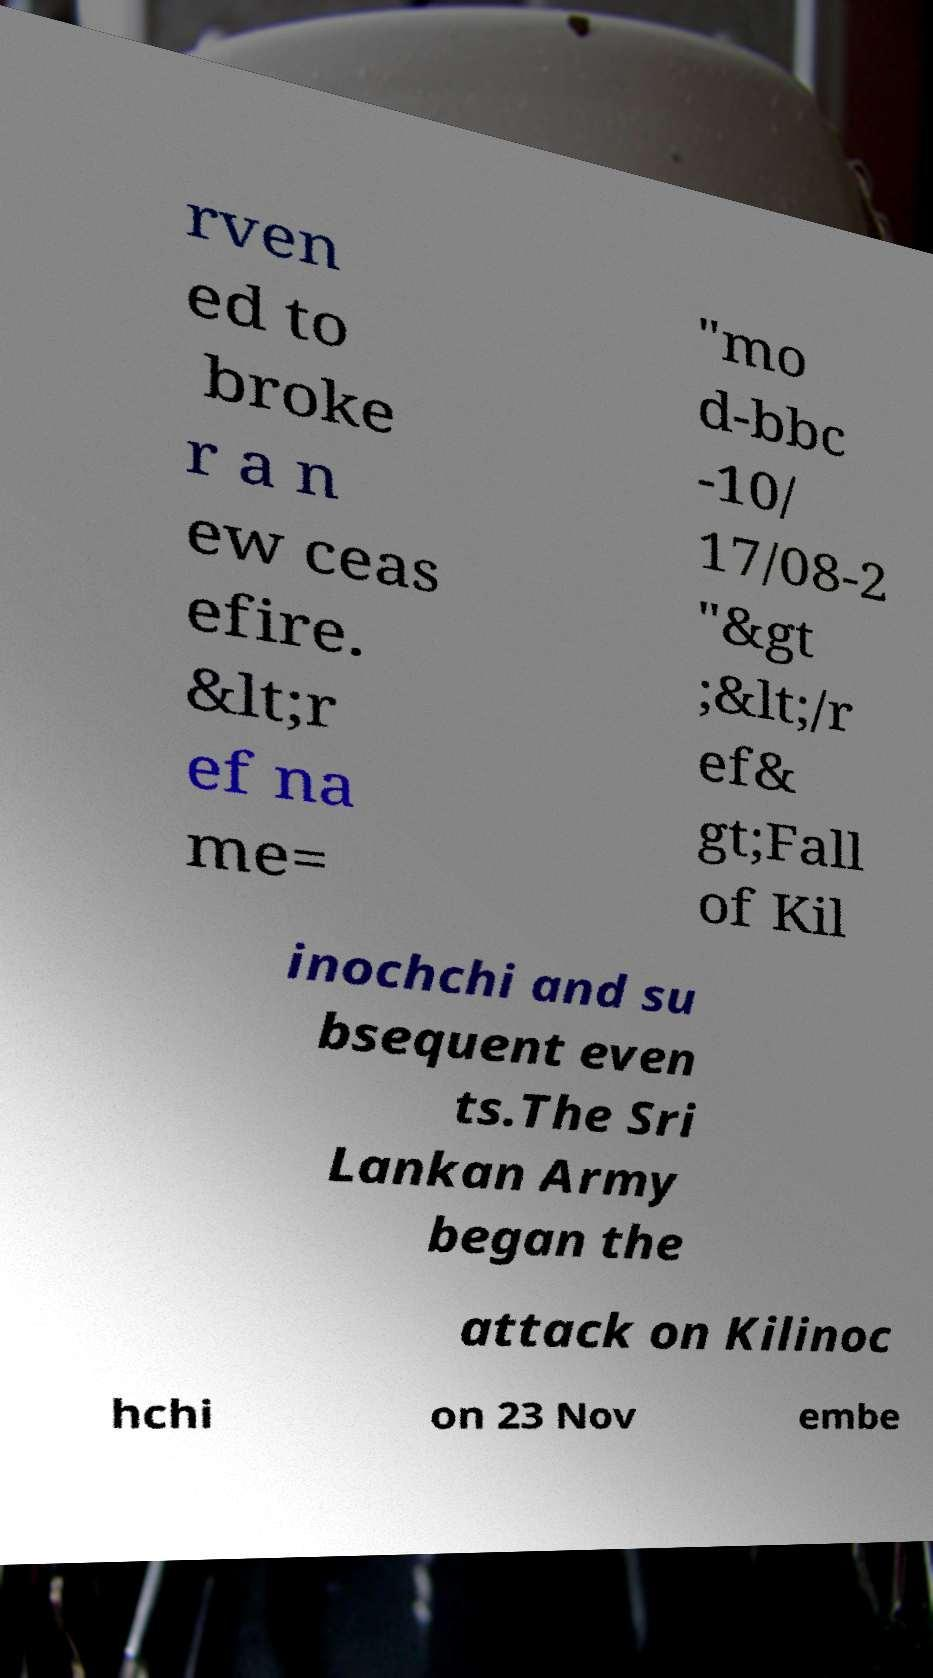I need the written content from this picture converted into text. Can you do that? rven ed to broke r a n ew ceas efire. &lt;r ef na me= "mo d-bbc -10/ 17/08-2 "&gt ;&lt;/r ef& gt;Fall of Kil inochchi and su bsequent even ts.The Sri Lankan Army began the attack on Kilinoc hchi on 23 Nov embe 